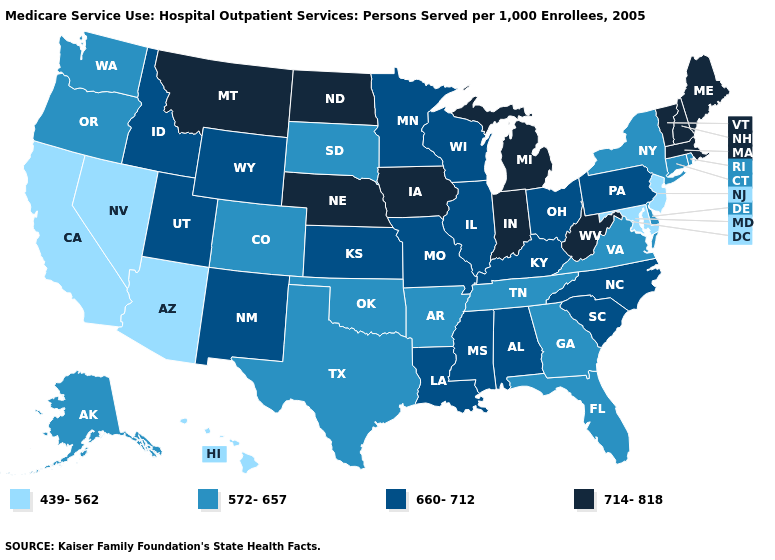Does Tennessee have the highest value in the South?
Give a very brief answer. No. Which states hav the highest value in the Northeast?
Quick response, please. Maine, Massachusetts, New Hampshire, Vermont. Name the states that have a value in the range 439-562?
Give a very brief answer. Arizona, California, Hawaii, Maryland, Nevada, New Jersey. Does Alaska have a higher value than Nevada?
Quick response, please. Yes. What is the value of Vermont?
Give a very brief answer. 714-818. What is the value of Ohio?
Be succinct. 660-712. Which states have the highest value in the USA?
Keep it brief. Indiana, Iowa, Maine, Massachusetts, Michigan, Montana, Nebraska, New Hampshire, North Dakota, Vermont, West Virginia. Does Michigan have the highest value in the USA?
Quick response, please. Yes. Name the states that have a value in the range 660-712?
Quick response, please. Alabama, Idaho, Illinois, Kansas, Kentucky, Louisiana, Minnesota, Mississippi, Missouri, New Mexico, North Carolina, Ohio, Pennsylvania, South Carolina, Utah, Wisconsin, Wyoming. What is the lowest value in the Northeast?
Write a very short answer. 439-562. Does Maine have the highest value in the USA?
Keep it brief. Yes. Does North Dakota have the same value as Idaho?
Quick response, please. No. Name the states that have a value in the range 714-818?
Give a very brief answer. Indiana, Iowa, Maine, Massachusetts, Michigan, Montana, Nebraska, New Hampshire, North Dakota, Vermont, West Virginia. How many symbols are there in the legend?
Concise answer only. 4. 